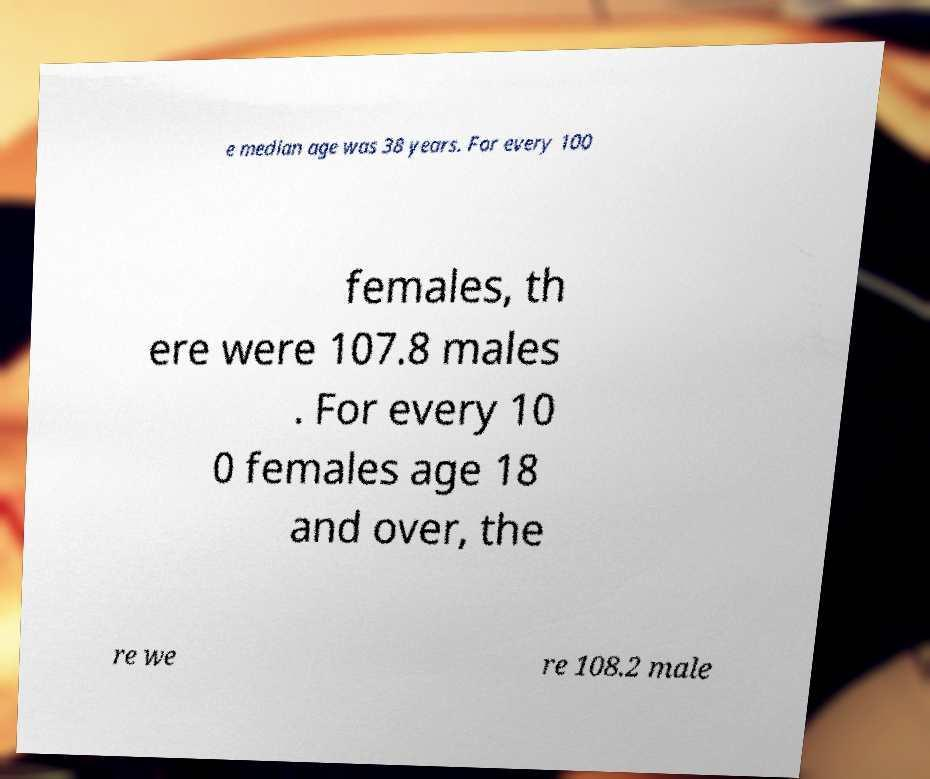What messages or text are displayed in this image? I need them in a readable, typed format. e median age was 38 years. For every 100 females, th ere were 107.8 males . For every 10 0 females age 18 and over, the re we re 108.2 male 